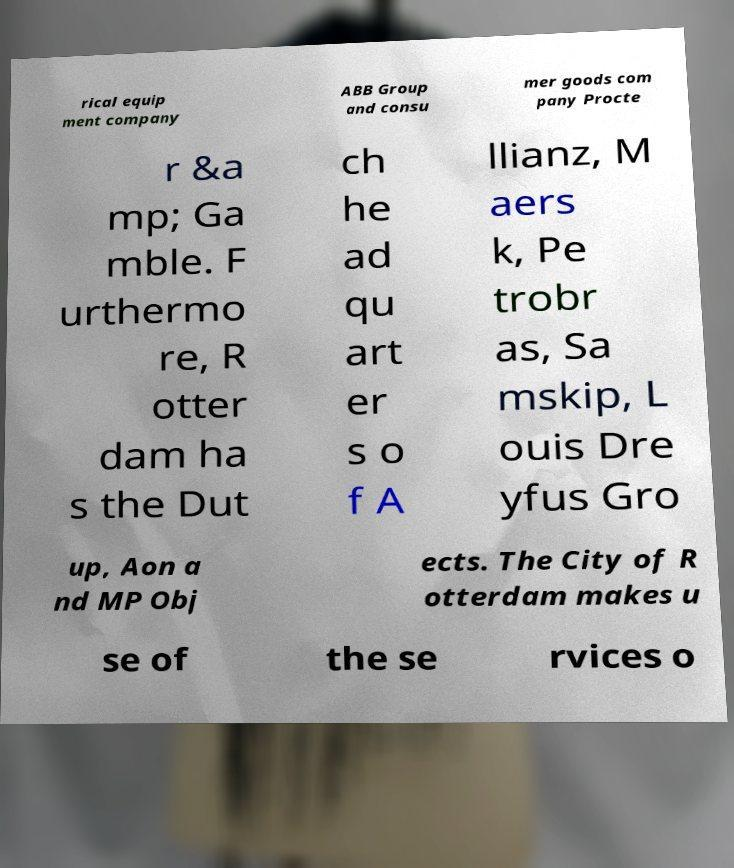Please read and relay the text visible in this image. What does it say? rical equip ment company ABB Group and consu mer goods com pany Procte r &a mp; Ga mble. F urthermo re, R otter dam ha s the Dut ch he ad qu art er s o f A llianz, M aers k, Pe trobr as, Sa mskip, L ouis Dre yfus Gro up, Aon a nd MP Obj ects. The City of R otterdam makes u se of the se rvices o 